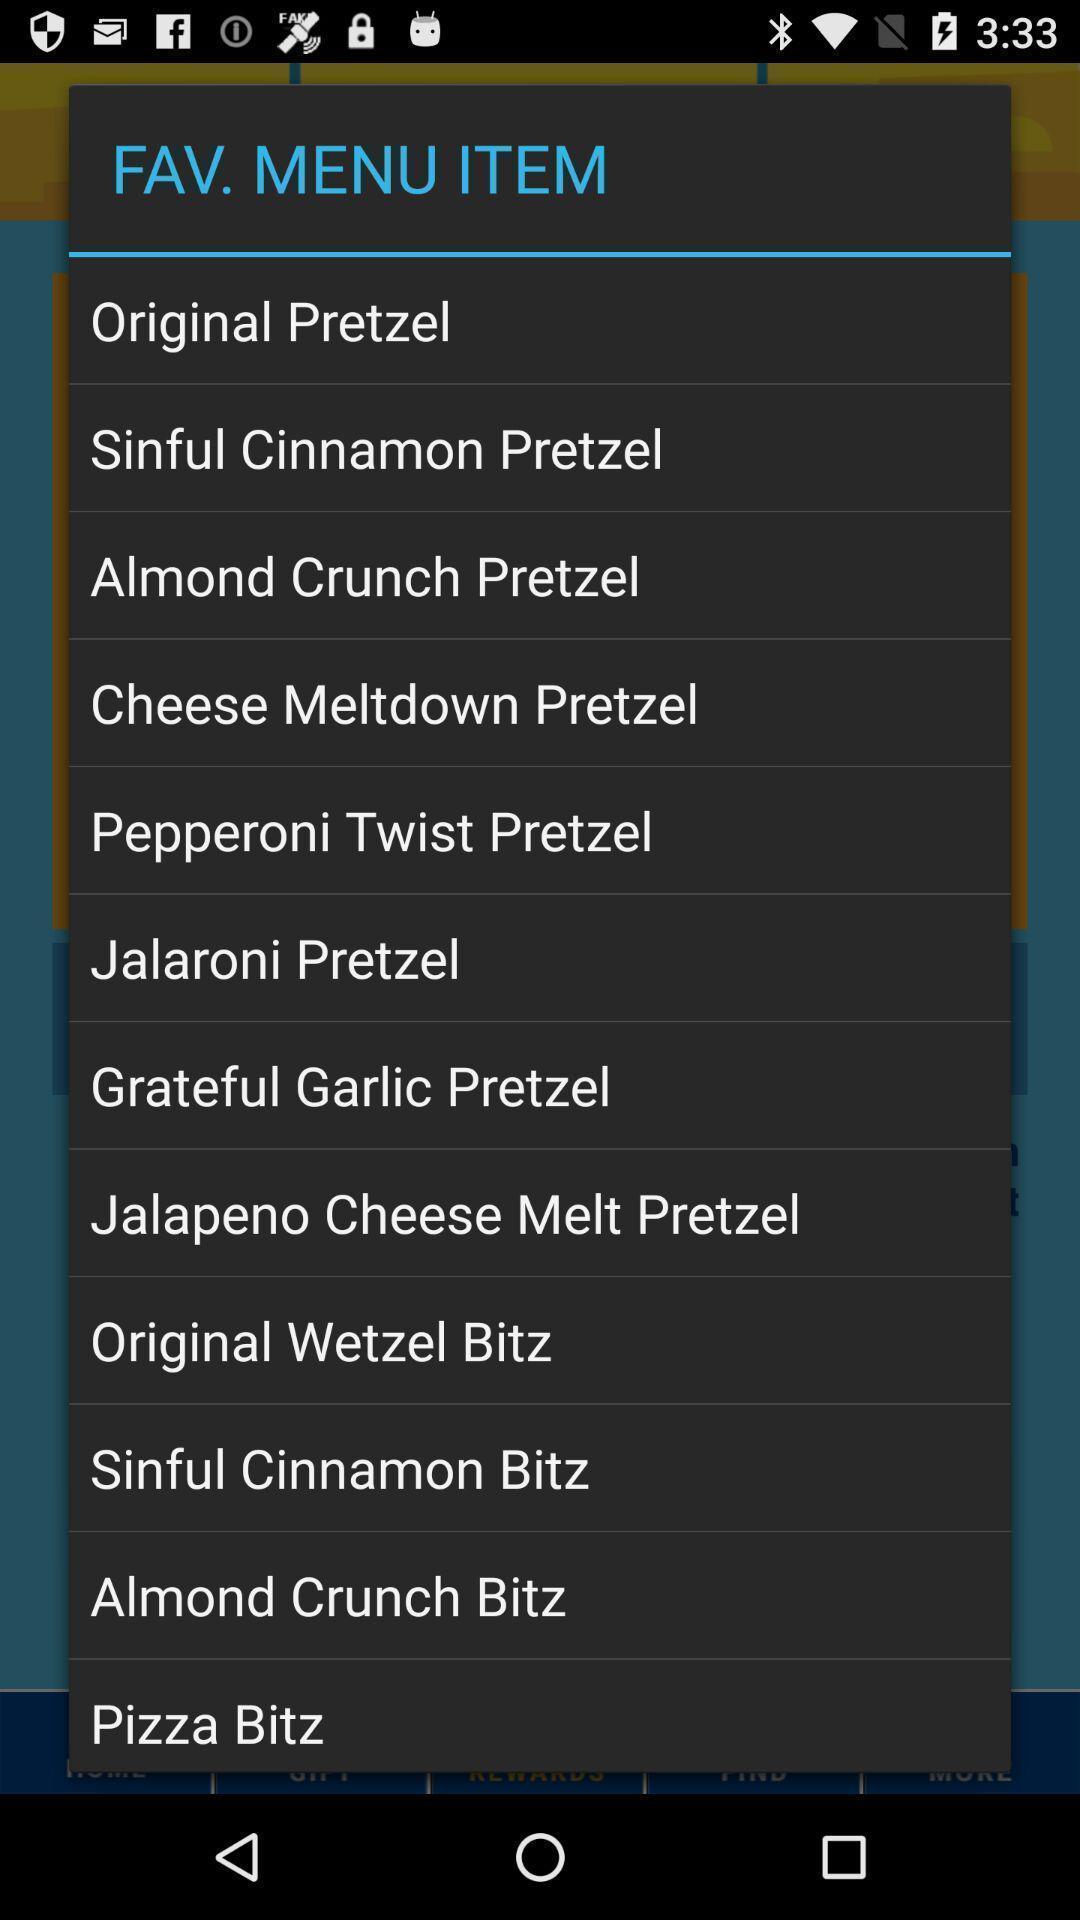Explain what's happening in this screen capture. Pop-up displaying to select an item among the list. 